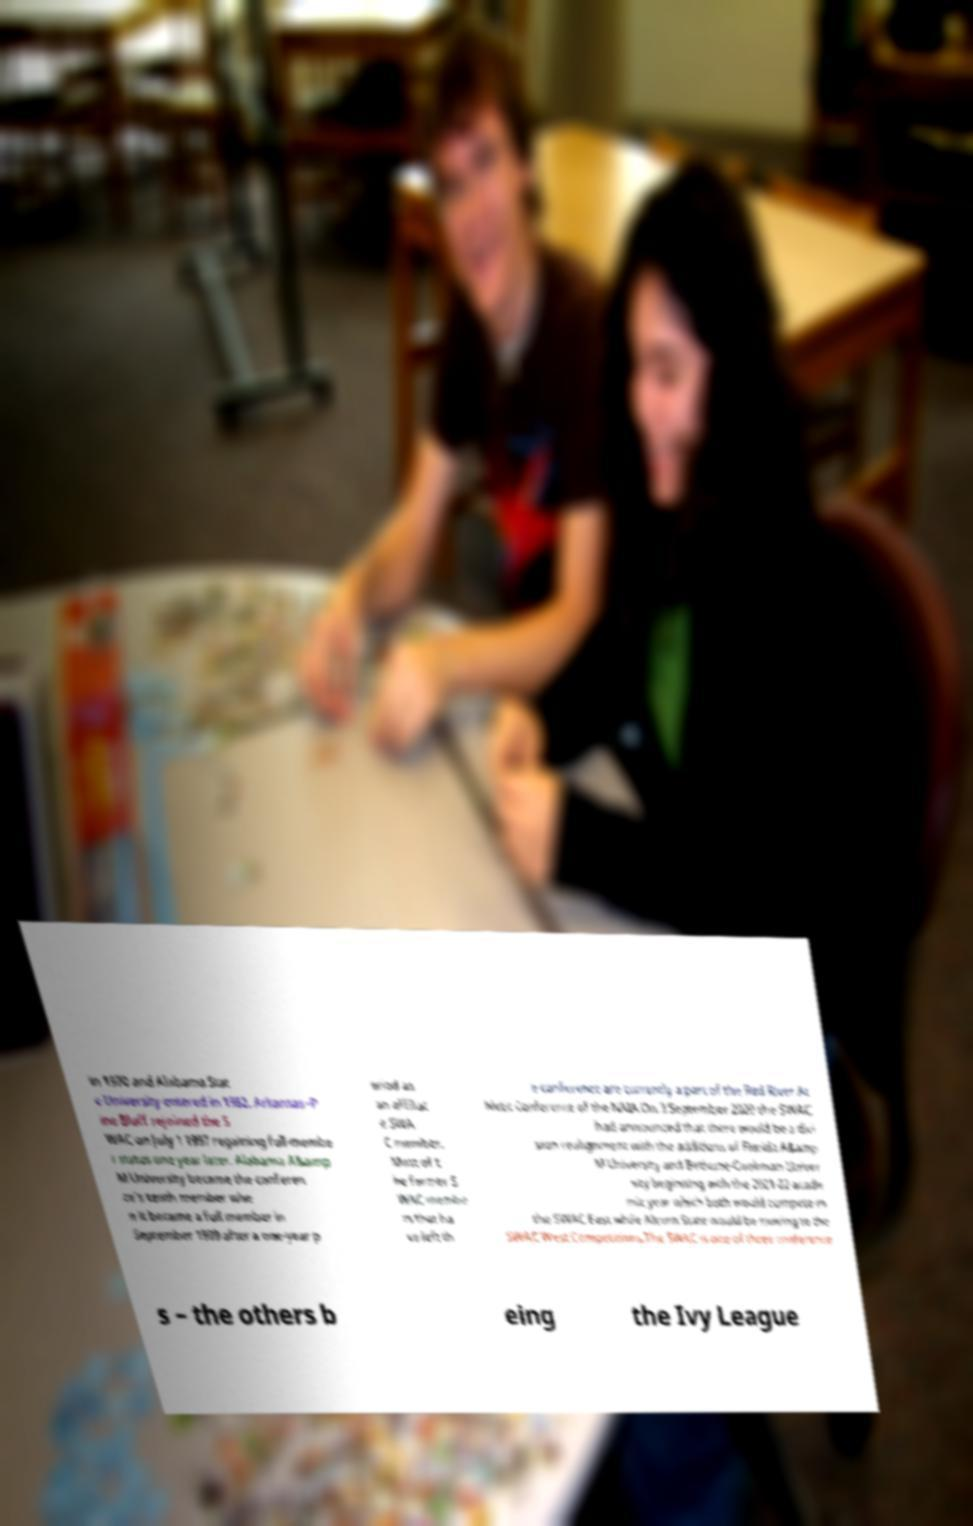Could you assist in decoding the text presented in this image and type it out clearly? in 1970 and Alabama Stat e University entered in 1982. Arkansas–P ine Bluff rejoined the S WAC on July 1 1997 regaining full-membe r status one year later. Alabama A&amp M University became the conferen ce’s tenth member whe n it became a full member in September 1999 after a one-year p eriod as an affiliat e SWA C member. Most of t he former S WAC membe rs that ha ve left th e conference are currently a part of the Red River At hletic Conference of the NAIA.On 3 September 2020 the SWAC had announced that there would be a divi sion realignment with the additions of Florida A&amp M University and Bethune-Cookman Univer sity beginning with the 2021-22 acade mic year which both would compete in the SWAC East while Alcorn State would be moving to the SWAC West.Competitions.The SWAC is one of three conference s – the others b eing the Ivy League 